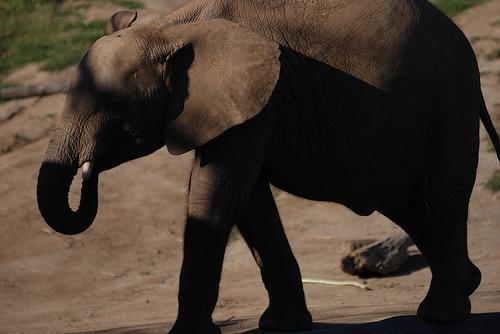How many elephants are visible?
Give a very brief answer. 1. 